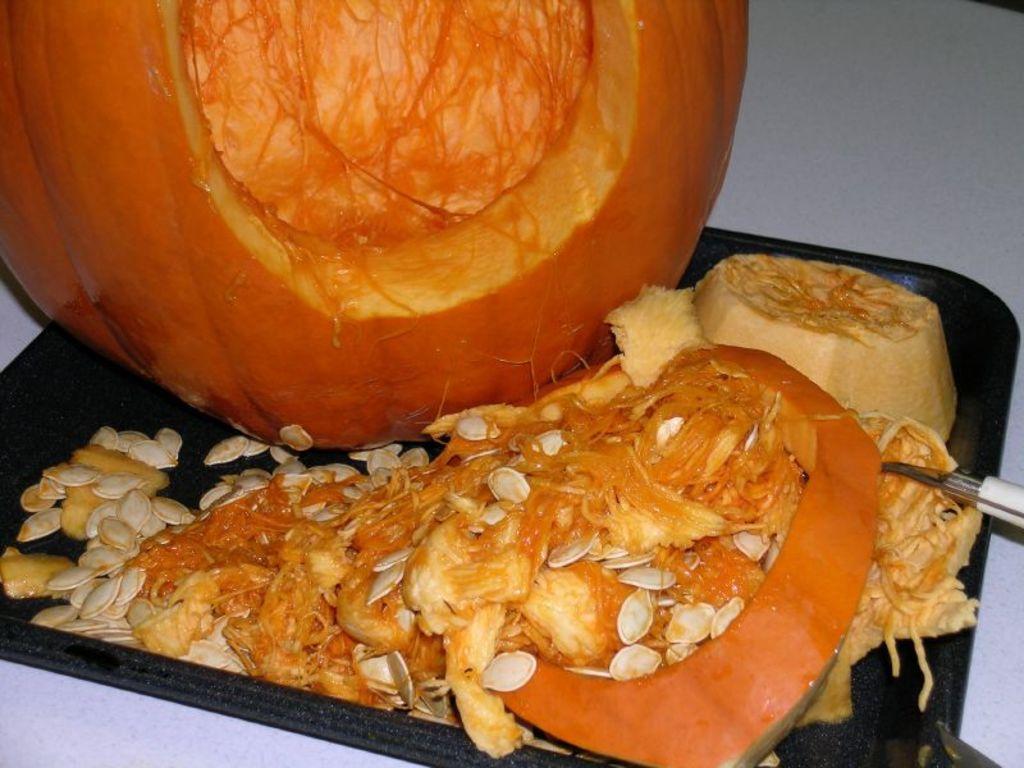Describe this image in one or two sentences. In this image we can see a pumpkin placed on the tray. On the right there is a peeler. At the bottom there is a table. 